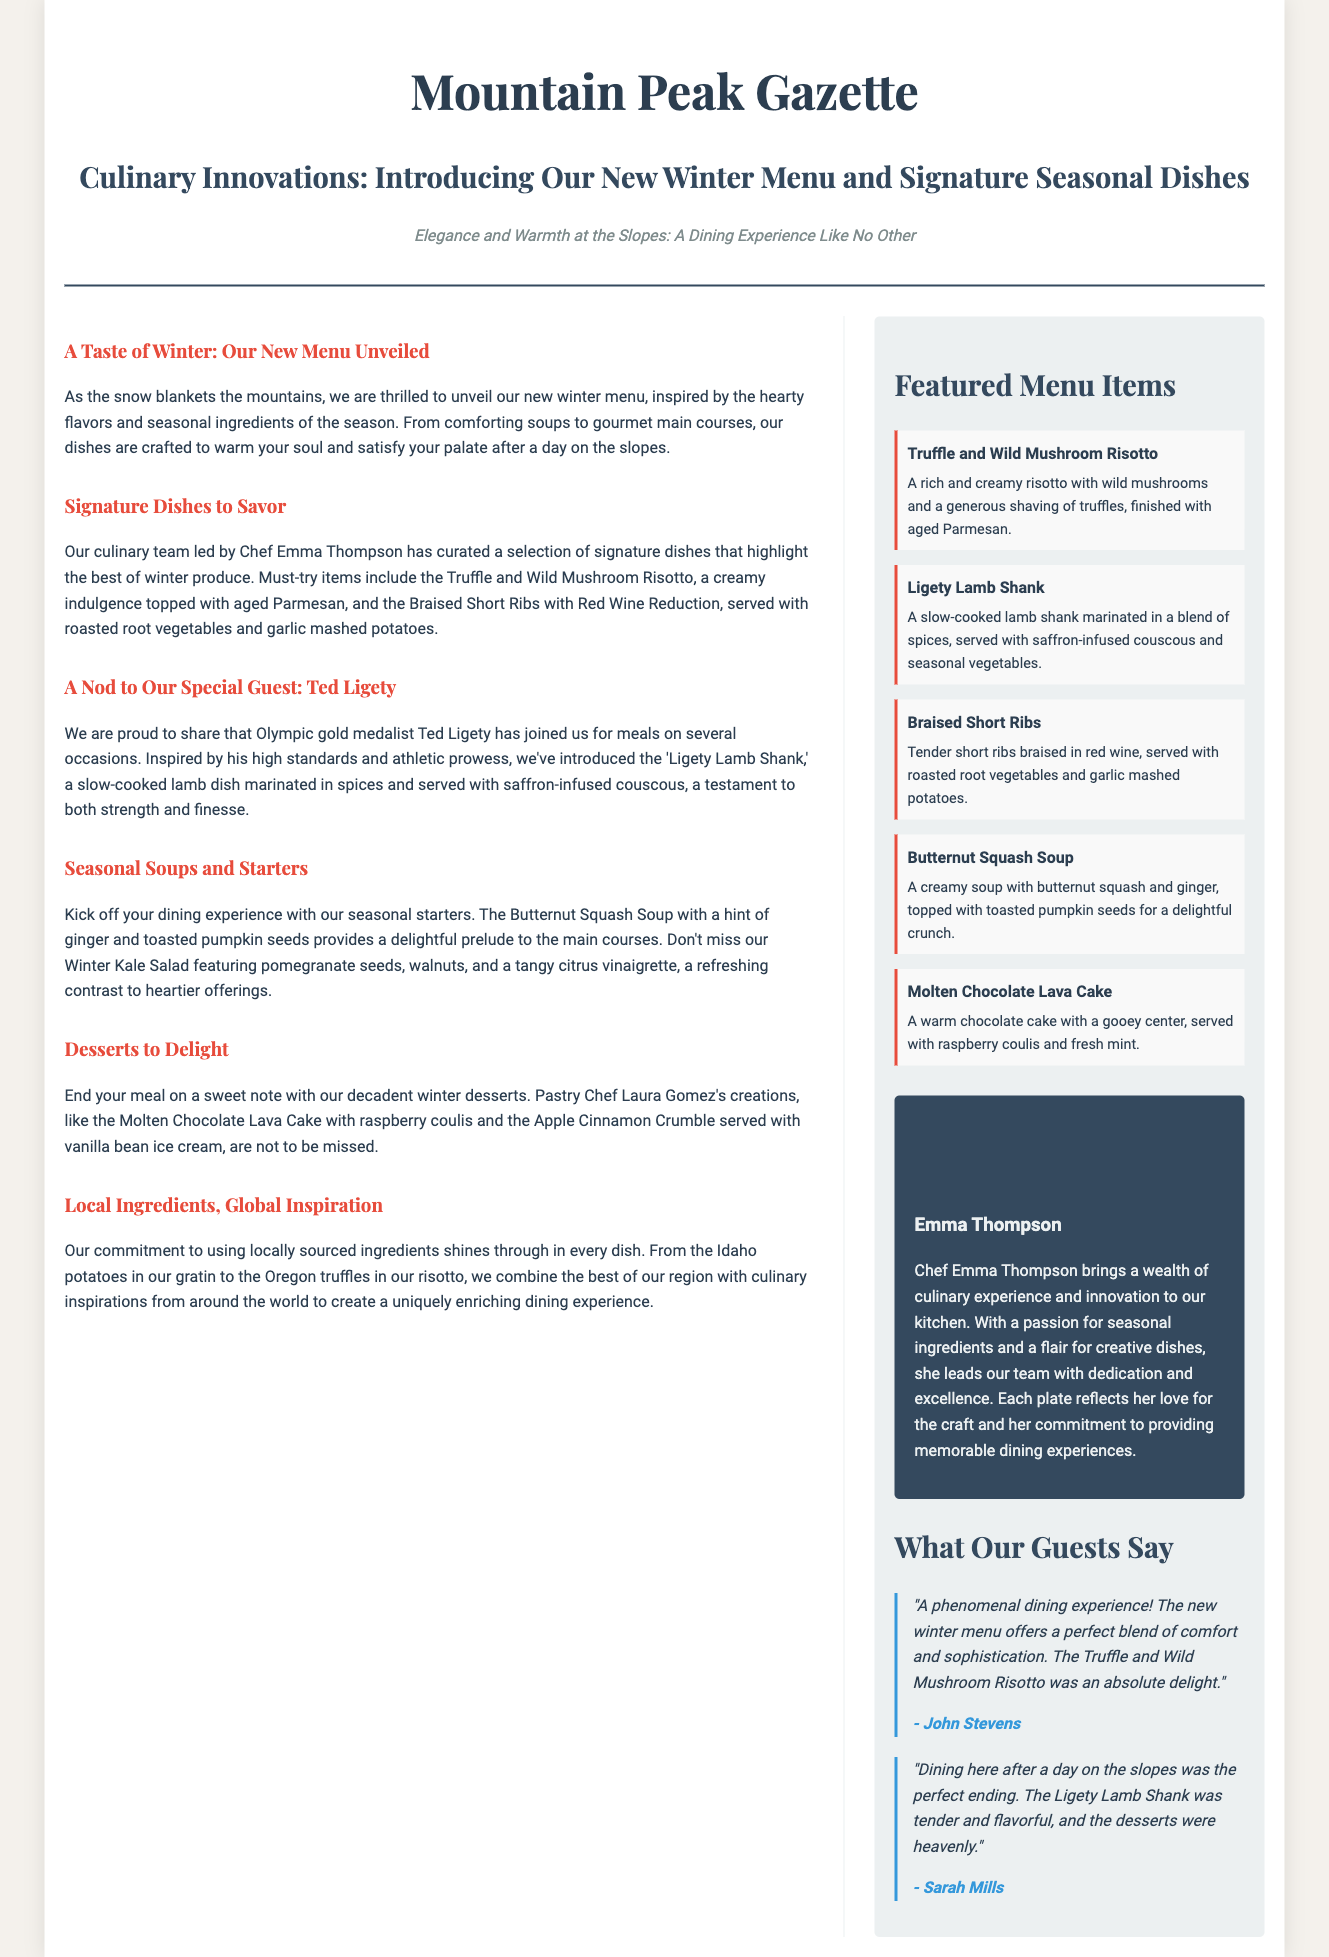What is the title of the article? The title of the article is presented prominently at the top and is "Culinary Innovations: Introducing Our New Winter Menu and Signature Seasonal Dishes."
Answer: Culinary Innovations: Introducing Our New Winter Menu and Signature Seasonal Dishes Who is the chef mentioned in the document? The chef mentioned in the document is responsible for creating the new winter menu and is named Emma Thompson.
Answer: Emma Thompson What dish is inspired by Ted Ligety? The document highlights a special dish that honors Ted Ligety, known as the "Ligety Lamb Shank."
Answer: Ligety Lamb Shank What type of soup is included in the seasonal starters? The document lists a soup that serves as a seasonal starter, specifically the Butternut Squash Soup.
Answer: Butternut Squash Soup Which dessert is paired with raspberry coulis? The dessert mentioned in the document that is served with raspberry coulis is the Molten Chocolate Lava Cake.
Answer: Molten Chocolate Lava Cake How many featured menu items are listed in the sidebar? The sidebar of the document includes a total of five featured menu items.
Answer: Five What is Chef Emma Thompson's focus in the kitchen? The document describes Chef Emma Thompson's culinary focus as utilizing seasonal ingredients.
Answer: Seasonal ingredients What is John Stevens' opinion about the dining experience? John Stevens provides feedback on the dining experience, stating it was a "phenomenal dining experience."
Answer: phenomenal dining experience 